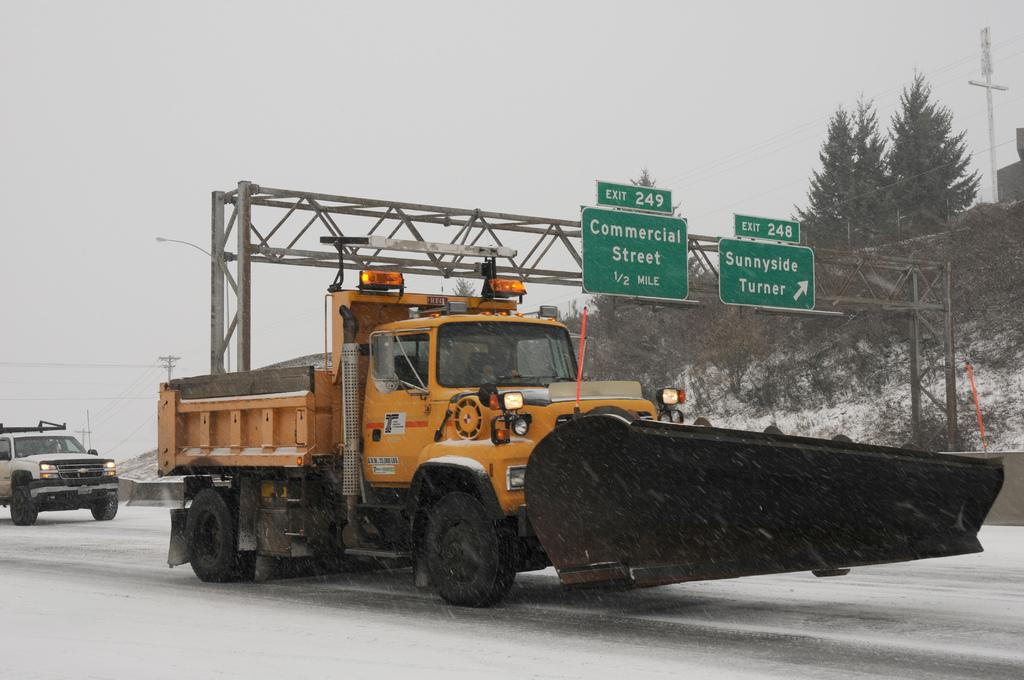How many vehicles can be seen on the road in the image? There are two vehicles on the road in the image. What can be seen in the background of the image? In the background, there are rods, trees, name boards, sign boards, plants, snow, poles, wires, and the sky. Can you describe the environment in the background? The background features a mix of natural elements like trees and snow, as well as man-made structures such as name boards, sign boards, poles, and wires. What type of vegetable is being sold on the table in the image? There is no table or produce present in the image; it features two vehicles on the road and various elements in the background. 